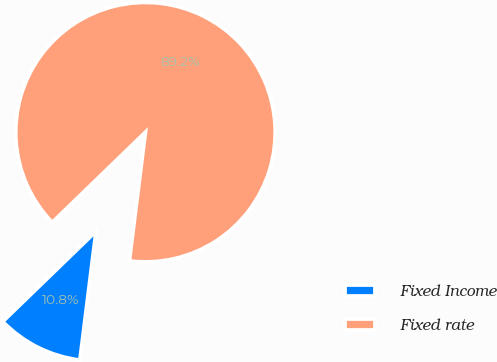Convert chart to OTSL. <chart><loc_0><loc_0><loc_500><loc_500><pie_chart><fcel>Fixed Income<fcel>Fixed rate<nl><fcel>10.78%<fcel>89.22%<nl></chart> 